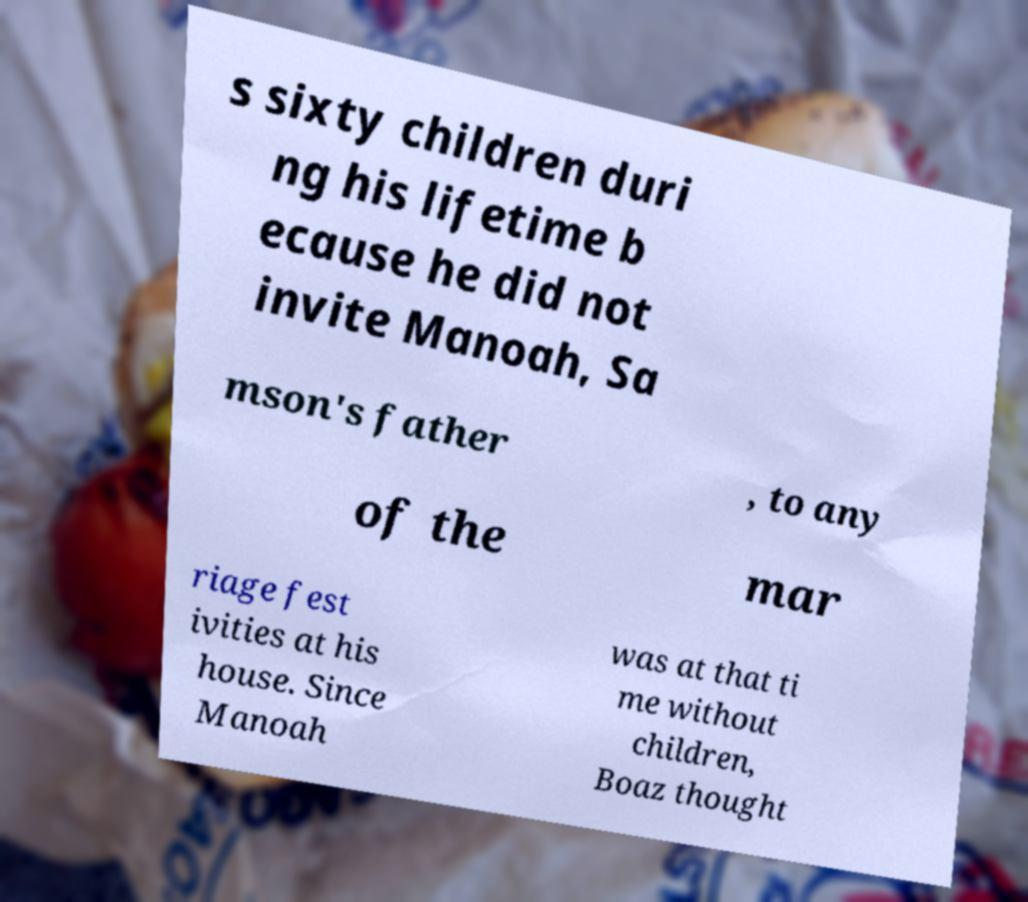Could you assist in decoding the text presented in this image and type it out clearly? s sixty children duri ng his lifetime b ecause he did not invite Manoah, Sa mson's father , to any of the mar riage fest ivities at his house. Since Manoah was at that ti me without children, Boaz thought 